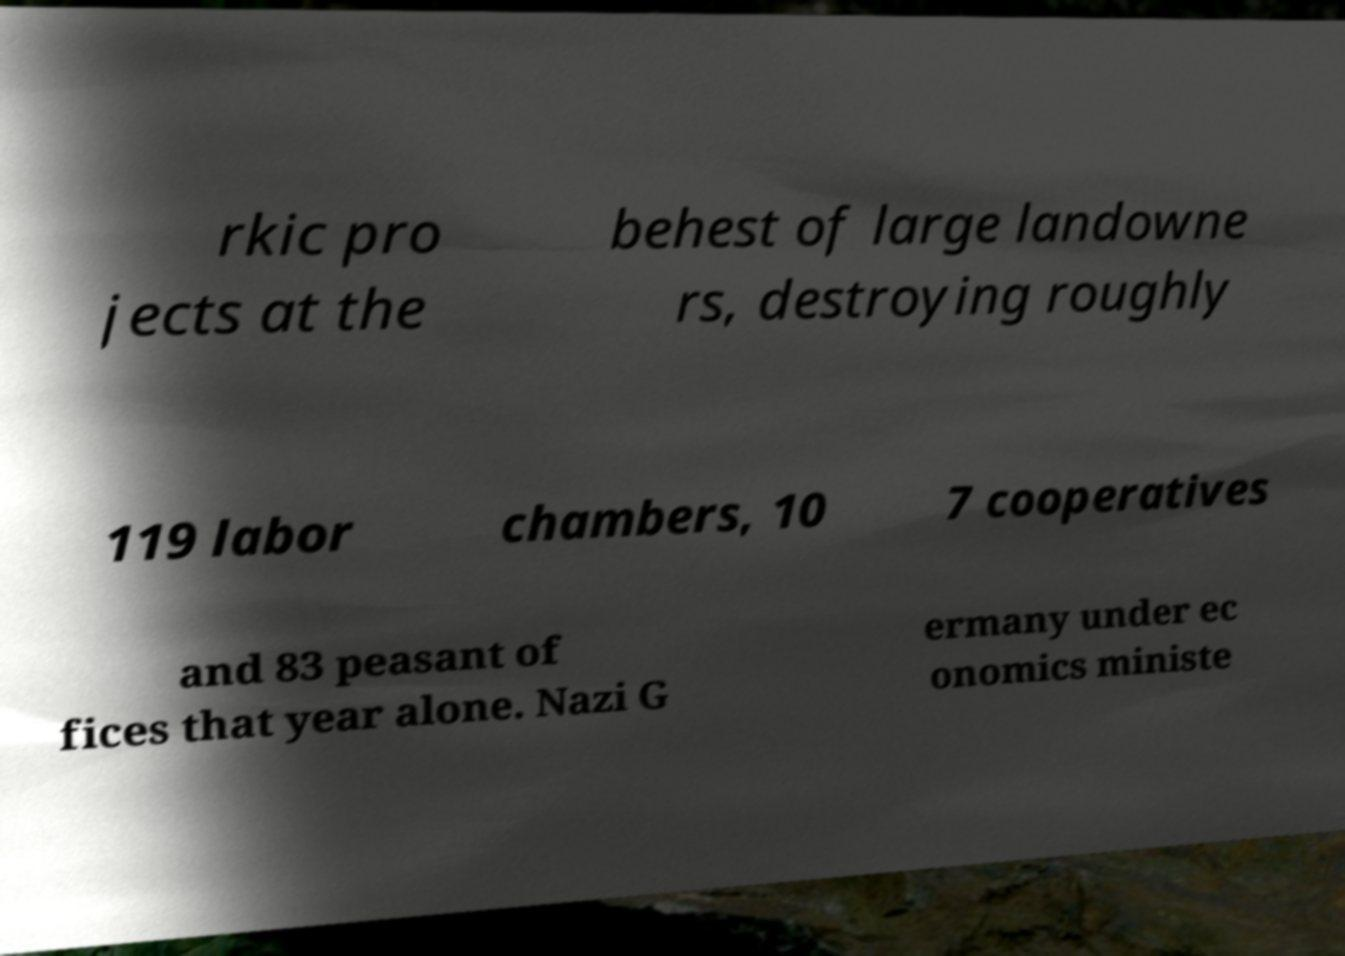For documentation purposes, I need the text within this image transcribed. Could you provide that? rkic pro jects at the behest of large landowne rs, destroying roughly 119 labor chambers, 10 7 cooperatives and 83 peasant of fices that year alone. Nazi G ermany under ec onomics ministe 